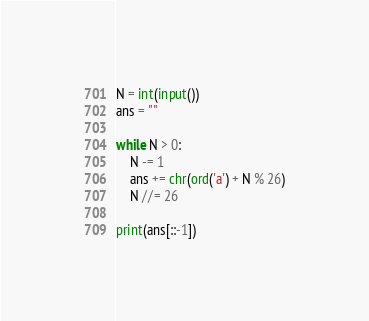<code> <loc_0><loc_0><loc_500><loc_500><_Python_>N = int(input())
ans = ""

while N > 0:
	N -= 1
	ans += chr(ord('a') + N % 26)
	N //= 26

print(ans[::-1])</code> 